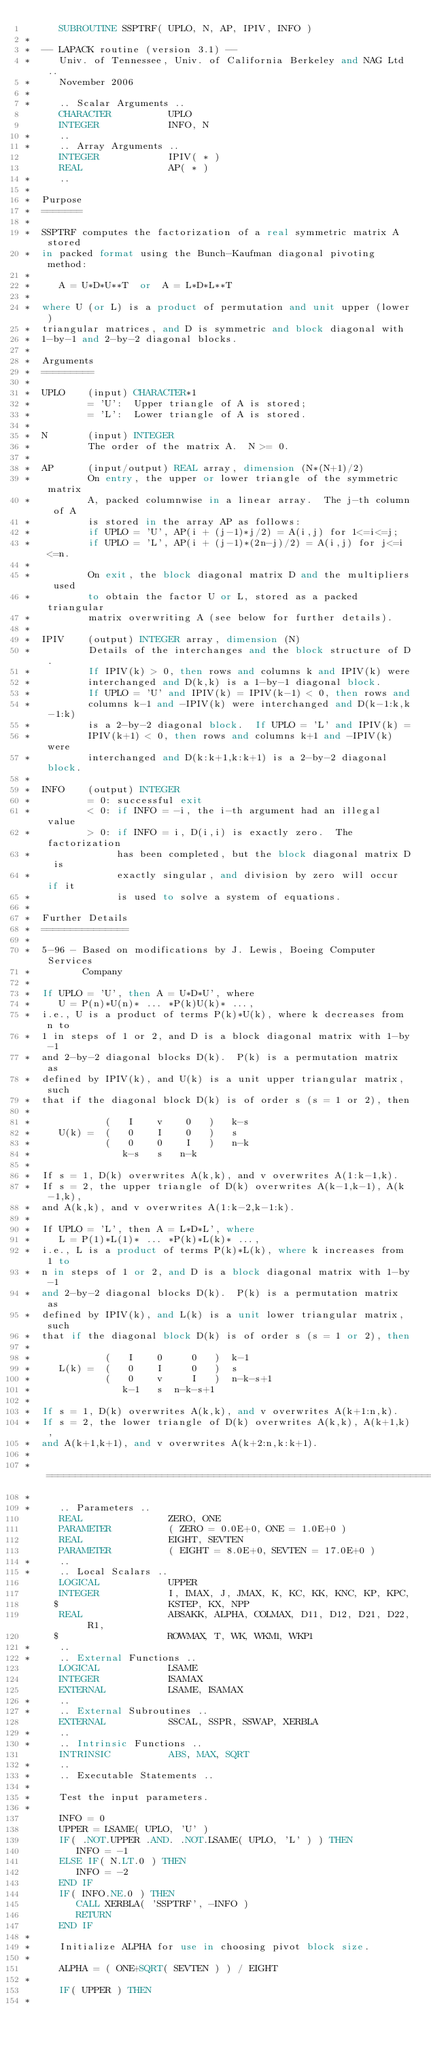Convert code to text. <code><loc_0><loc_0><loc_500><loc_500><_FORTRAN_>      SUBROUTINE SSPTRF( UPLO, N, AP, IPIV, INFO )
*
*  -- LAPACK routine (version 3.1) --
*     Univ. of Tennessee, Univ. of California Berkeley and NAG Ltd..
*     November 2006
*
*     .. Scalar Arguments ..
      CHARACTER          UPLO
      INTEGER            INFO, N
*     ..
*     .. Array Arguments ..
      INTEGER            IPIV( * )
      REAL               AP( * )
*     ..
*
*  Purpose
*  =======
*
*  SSPTRF computes the factorization of a real symmetric matrix A stored
*  in packed format using the Bunch-Kaufman diagonal pivoting method:
*
*     A = U*D*U**T  or  A = L*D*L**T
*
*  where U (or L) is a product of permutation and unit upper (lower)
*  triangular matrices, and D is symmetric and block diagonal with
*  1-by-1 and 2-by-2 diagonal blocks.
*
*  Arguments
*  =========
*
*  UPLO    (input) CHARACTER*1
*          = 'U':  Upper triangle of A is stored;
*          = 'L':  Lower triangle of A is stored.
*
*  N       (input) INTEGER
*          The order of the matrix A.  N >= 0.
*
*  AP      (input/output) REAL array, dimension (N*(N+1)/2)
*          On entry, the upper or lower triangle of the symmetric matrix
*          A, packed columnwise in a linear array.  The j-th column of A
*          is stored in the array AP as follows:
*          if UPLO = 'U', AP(i + (j-1)*j/2) = A(i,j) for 1<=i<=j;
*          if UPLO = 'L', AP(i + (j-1)*(2n-j)/2) = A(i,j) for j<=i<=n.
*
*          On exit, the block diagonal matrix D and the multipliers used
*          to obtain the factor U or L, stored as a packed triangular
*          matrix overwriting A (see below for further details).
*
*  IPIV    (output) INTEGER array, dimension (N)
*          Details of the interchanges and the block structure of D.
*          If IPIV(k) > 0, then rows and columns k and IPIV(k) were
*          interchanged and D(k,k) is a 1-by-1 diagonal block.
*          If UPLO = 'U' and IPIV(k) = IPIV(k-1) < 0, then rows and
*          columns k-1 and -IPIV(k) were interchanged and D(k-1:k,k-1:k)
*          is a 2-by-2 diagonal block.  If UPLO = 'L' and IPIV(k) =
*          IPIV(k+1) < 0, then rows and columns k+1 and -IPIV(k) were
*          interchanged and D(k:k+1,k:k+1) is a 2-by-2 diagonal block.
*
*  INFO    (output) INTEGER
*          = 0: successful exit
*          < 0: if INFO = -i, the i-th argument had an illegal value
*          > 0: if INFO = i, D(i,i) is exactly zero.  The factorization
*               has been completed, but the block diagonal matrix D is
*               exactly singular, and division by zero will occur if it
*               is used to solve a system of equations.
*
*  Further Details
*  ===============
*
*  5-96 - Based on modifications by J. Lewis, Boeing Computer Services
*         Company
*
*  If UPLO = 'U', then A = U*D*U', where
*     U = P(n)*U(n)* ... *P(k)U(k)* ...,
*  i.e., U is a product of terms P(k)*U(k), where k decreases from n to
*  1 in steps of 1 or 2, and D is a block diagonal matrix with 1-by-1
*  and 2-by-2 diagonal blocks D(k).  P(k) is a permutation matrix as
*  defined by IPIV(k), and U(k) is a unit upper triangular matrix, such
*  that if the diagonal block D(k) is of order s (s = 1 or 2), then
*
*             (   I    v    0   )   k-s
*     U(k) =  (   0    I    0   )   s
*             (   0    0    I   )   n-k
*                k-s   s   n-k
*
*  If s = 1, D(k) overwrites A(k,k), and v overwrites A(1:k-1,k).
*  If s = 2, the upper triangle of D(k) overwrites A(k-1,k-1), A(k-1,k),
*  and A(k,k), and v overwrites A(1:k-2,k-1:k).
*
*  If UPLO = 'L', then A = L*D*L', where
*     L = P(1)*L(1)* ... *P(k)*L(k)* ...,
*  i.e., L is a product of terms P(k)*L(k), where k increases from 1 to
*  n in steps of 1 or 2, and D is a block diagonal matrix with 1-by-1
*  and 2-by-2 diagonal blocks D(k).  P(k) is a permutation matrix as
*  defined by IPIV(k), and L(k) is a unit lower triangular matrix, such
*  that if the diagonal block D(k) is of order s (s = 1 or 2), then
*
*             (   I    0     0   )  k-1
*     L(k) =  (   0    I     0   )  s
*             (   0    v     I   )  n-k-s+1
*                k-1   s  n-k-s+1
*
*  If s = 1, D(k) overwrites A(k,k), and v overwrites A(k+1:n,k).
*  If s = 2, the lower triangle of D(k) overwrites A(k,k), A(k+1,k),
*  and A(k+1,k+1), and v overwrites A(k+2:n,k:k+1).
*
*  =====================================================================
*
*     .. Parameters ..
      REAL               ZERO, ONE
      PARAMETER          ( ZERO = 0.0E+0, ONE = 1.0E+0 )
      REAL               EIGHT, SEVTEN
      PARAMETER          ( EIGHT = 8.0E+0, SEVTEN = 17.0E+0 )
*     ..
*     .. Local Scalars ..
      LOGICAL            UPPER
      INTEGER            I, IMAX, J, JMAX, K, KC, KK, KNC, KP, KPC,
     $                   KSTEP, KX, NPP
      REAL               ABSAKK, ALPHA, COLMAX, D11, D12, D21, D22, R1,
     $                   ROWMAX, T, WK, WKM1, WKP1
*     ..
*     .. External Functions ..
      LOGICAL            LSAME
      INTEGER            ISAMAX
      EXTERNAL           LSAME, ISAMAX
*     ..
*     .. External Subroutines ..
      EXTERNAL           SSCAL, SSPR, SSWAP, XERBLA
*     ..
*     .. Intrinsic Functions ..
      INTRINSIC          ABS, MAX, SQRT
*     ..
*     .. Executable Statements ..
*
*     Test the input parameters.
*
      INFO = 0
      UPPER = LSAME( UPLO, 'U' )
      IF( .NOT.UPPER .AND. .NOT.LSAME( UPLO, 'L' ) ) THEN
         INFO = -1
      ELSE IF( N.LT.0 ) THEN
         INFO = -2
      END IF
      IF( INFO.NE.0 ) THEN
         CALL XERBLA( 'SSPTRF', -INFO )
         RETURN
      END IF
*
*     Initialize ALPHA for use in choosing pivot block size.
*
      ALPHA = ( ONE+SQRT( SEVTEN ) ) / EIGHT
*
      IF( UPPER ) THEN
*</code> 